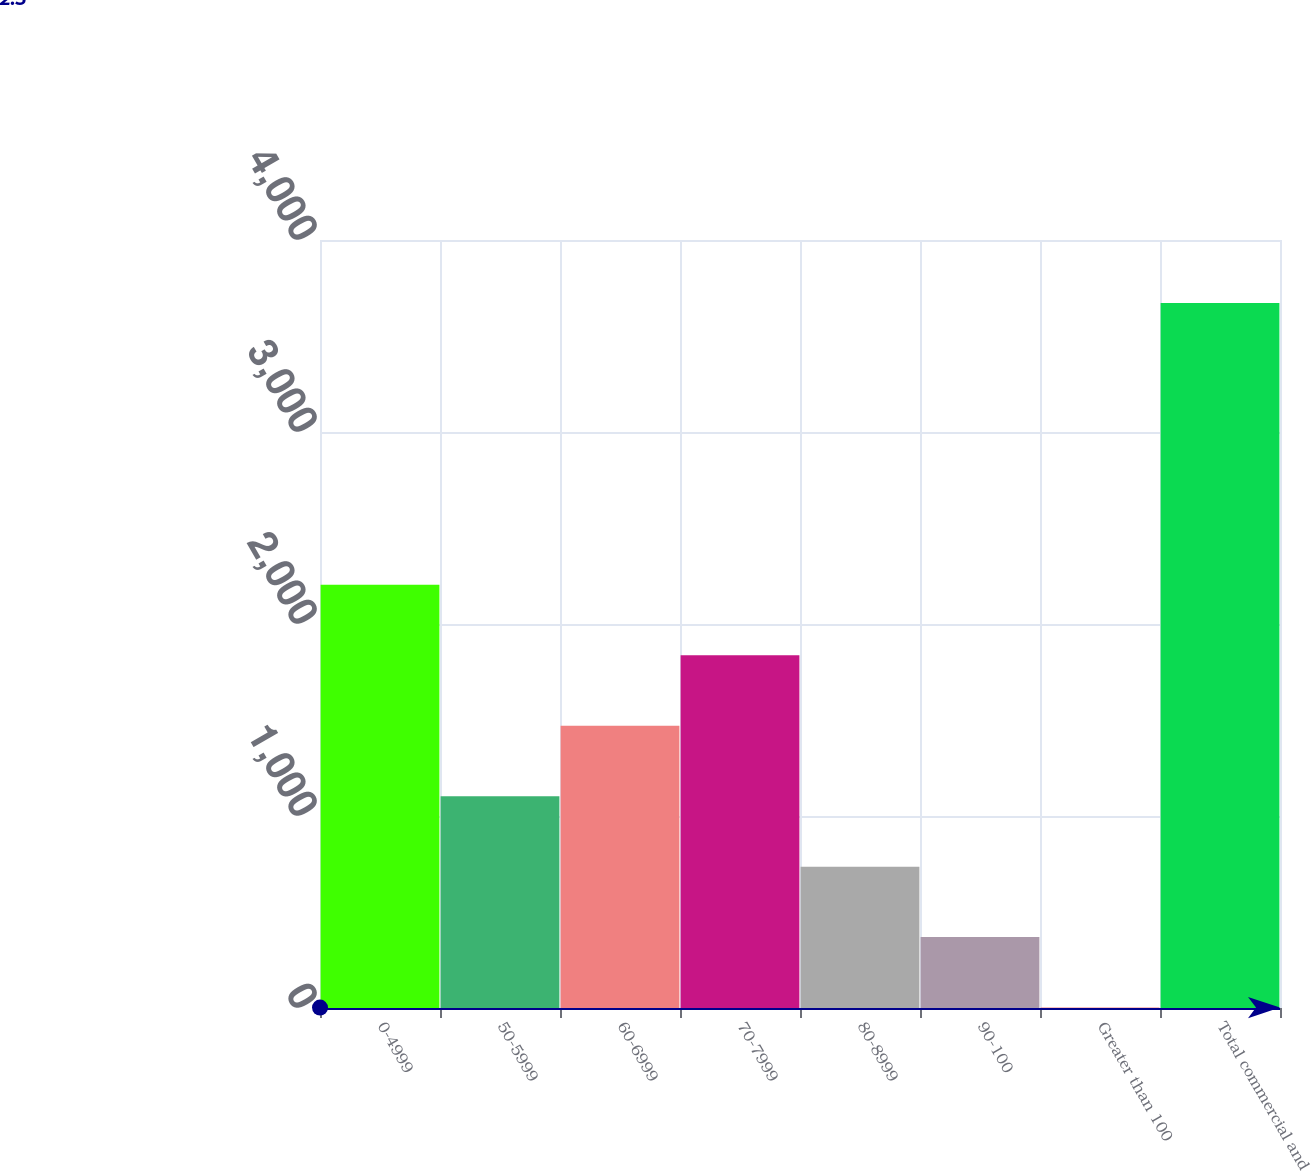Convert chart to OTSL. <chart><loc_0><loc_0><loc_500><loc_500><bar_chart><fcel>0-4999<fcel>50-5999<fcel>60-6999<fcel>70-7999<fcel>80-8999<fcel>90-100<fcel>Greater than 100<fcel>Total commercial and<nl><fcel>2204.12<fcel>1103.21<fcel>1470.18<fcel>1837.15<fcel>736.24<fcel>369.27<fcel>2.3<fcel>3672<nl></chart> 